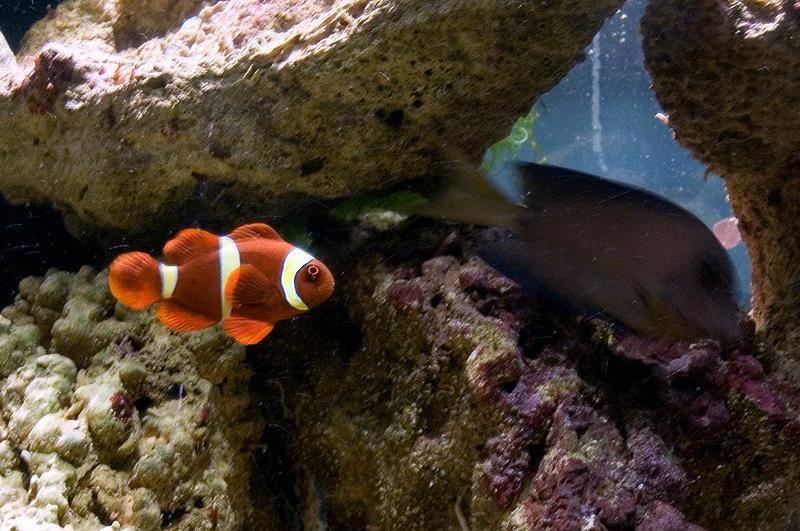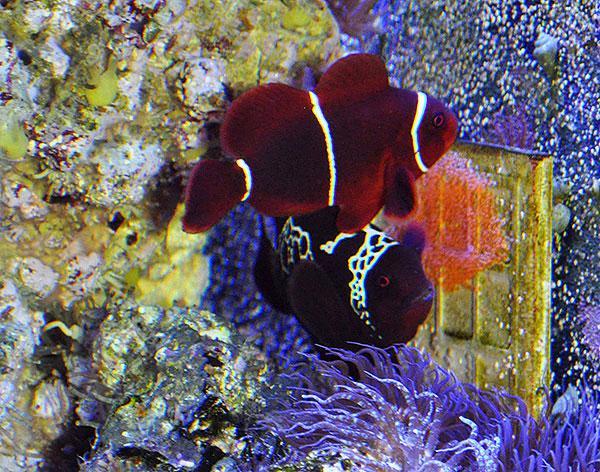The first image is the image on the left, the second image is the image on the right. Examine the images to the left and right. Is the description "One image shows bright yellow-orange clown fish with white stripes in and near anemone tendrils with a pinkish hue." accurate? Answer yes or no. No. The first image is the image on the left, the second image is the image on the right. For the images displayed, is the sentence "The clownfish in the left image is not actually within the anemone right now." factually correct? Answer yes or no. Yes. 